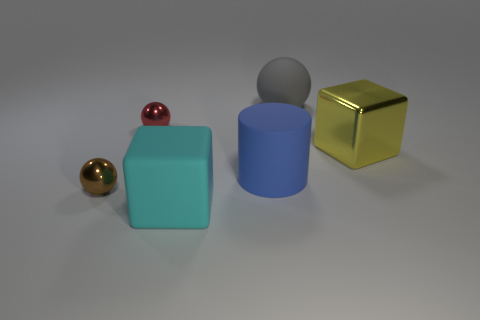Can you infer any potential uses for these objects? These objects appear to be simplistic geometric shapes that could be used for a variety of purposes. They might serve as educational tools for teaching geometry or as elements in a design or art project. The spheres could also be part of a larger sculpture or display. Without more context, the specific uses remain quite broad and speculative. 